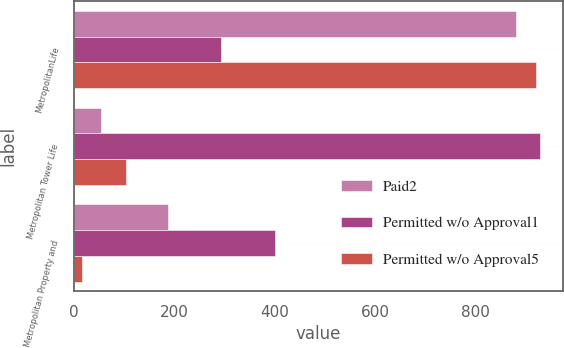<chart> <loc_0><loc_0><loc_500><loc_500><stacked_bar_chart><ecel><fcel>MetropolitanLife<fcel>Metropolitan Tower Life<fcel>Metropolitan Property and<nl><fcel>Paid2<fcel>880<fcel>54<fcel>187<nl><fcel>Permitted w/o Approval1<fcel>293.5<fcel>927<fcel>400<nl><fcel>Permitted w/o Approval5<fcel>919<fcel>104<fcel>16<nl></chart> 